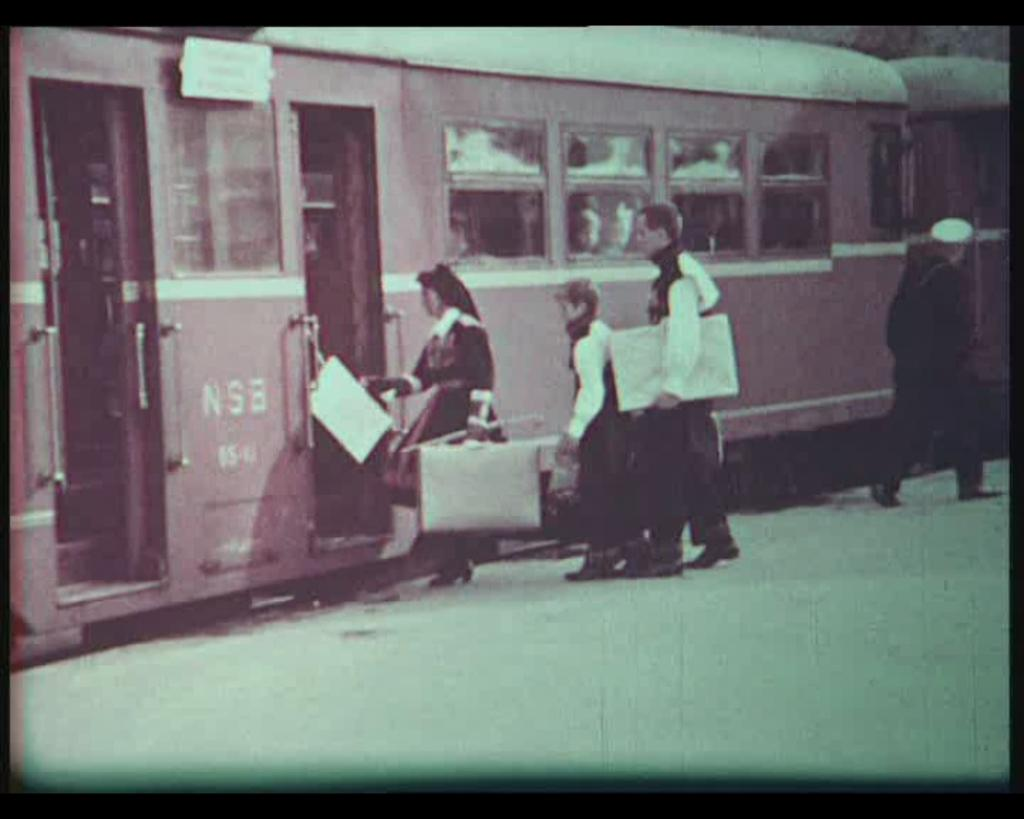What are the people in the image doing? The people in the image are standing on the ground. What are some of the people holding in their hands? Some of the people are holding objects in their hands. What can be seen in the background of the image? There is a train visible in the background of the image. Can you see a monkey playing with a blade in the oven in the image? No, there is no monkey, blade, or oven present in the image. 